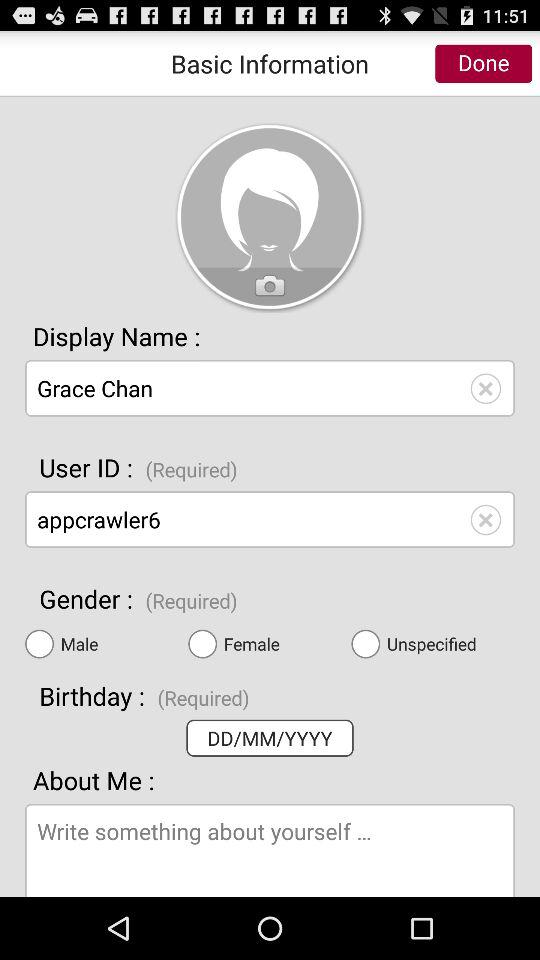Which gender was required?
When the provided information is insufficient, respond with <no answer>. <no answer> 